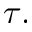Convert formula to latex. <formula><loc_0><loc_0><loc_500><loc_500>\tau .</formula> 